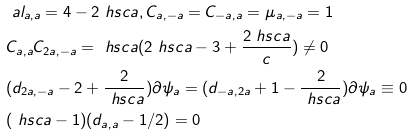Convert formula to latex. <formula><loc_0><loc_0><loc_500><loc_500>& \ a l _ { a , a } = 4 - 2 \ h s c { a } , C _ { a , - a } = C _ { - a , a } = \mu _ { a , - a } = 1 \\ & C _ { a , a } C _ { 2 a , - a } = \ h s c { a } ( 2 \ h s c { a } - 3 + \frac { 2 \ h s c { a } } { c } ) \neq 0 \\ & ( d _ { 2 a , - a } - 2 + \frac { 2 } { \ h s c { a } } ) \partial \psi _ { a } = ( d _ { - a , 2 a } + 1 - \frac { 2 } { \ h s c { a } } ) \partial \psi _ { a } \equiv 0 \\ & ( \ h s c { a } - 1 ) ( d _ { a , a } - 1 / 2 ) = 0</formula> 